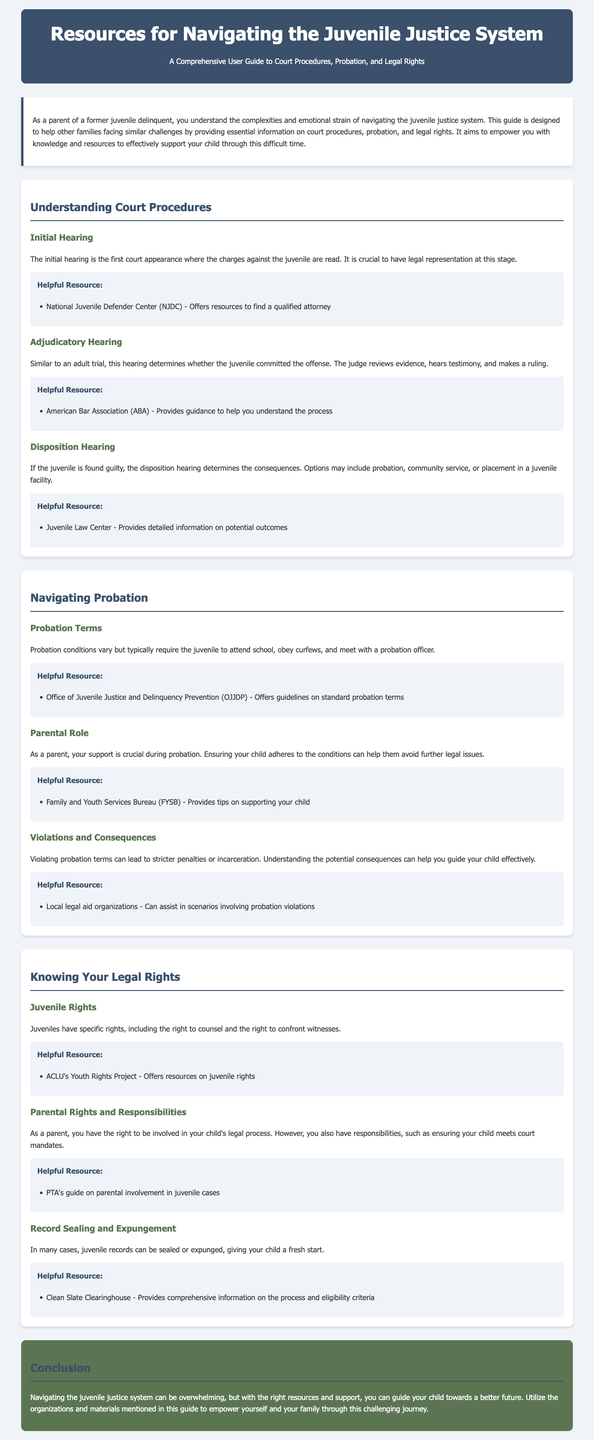What is the title of the guide? The title of the guide is prominently displayed at the top of the document.
Answer: Resources for Navigating the Juvenile Justice System What is the role of a parent during probation? The document explains the importance of parental support and involvement during probation.
Answer: Support What organization offers resources to find a qualified attorney? Information about helpful resources is listed under the court procedures section.
Answer: National Juvenile Defender Center What is determined at the disposition hearing? The document states that this hearing determines consequences for guilty juveniles.
Answer: Consequences Which organization provides guidance to help understand court procedures? The document mentions specific resources for understanding the adjudicatory hearing.
Answer: American Bar Association What is a potential outcome of a juvenile found guilty? The disposition hearing typically results in several options, which are listed in the guide.
Answer: Probation What rights do juveniles have? Specific rights of juveniles are highlighted in the legal rights section of the document.
Answer: Right to counsel What does the Clean Slate Clearinghouse provide information about? The document mentions this organization's focus concerning juvenile records.
Answer: Record sealing and expungement What is one responsibility of parents in the juvenile legal process? The document outlines parental responsibilities in relation to court mandates.
Answer: Ensure compliance 